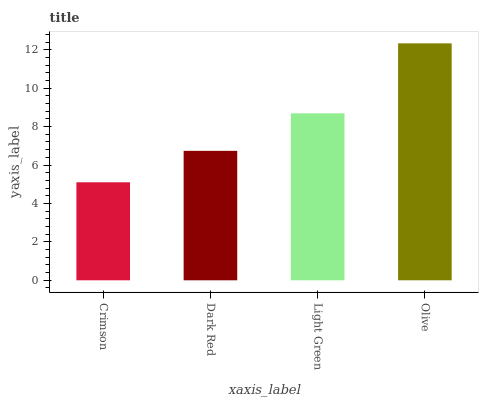Is Crimson the minimum?
Answer yes or no. Yes. Is Olive the maximum?
Answer yes or no. Yes. Is Dark Red the minimum?
Answer yes or no. No. Is Dark Red the maximum?
Answer yes or no. No. Is Dark Red greater than Crimson?
Answer yes or no. Yes. Is Crimson less than Dark Red?
Answer yes or no. Yes. Is Crimson greater than Dark Red?
Answer yes or no. No. Is Dark Red less than Crimson?
Answer yes or no. No. Is Light Green the high median?
Answer yes or no. Yes. Is Dark Red the low median?
Answer yes or no. Yes. Is Dark Red the high median?
Answer yes or no. No. Is Light Green the low median?
Answer yes or no. No. 